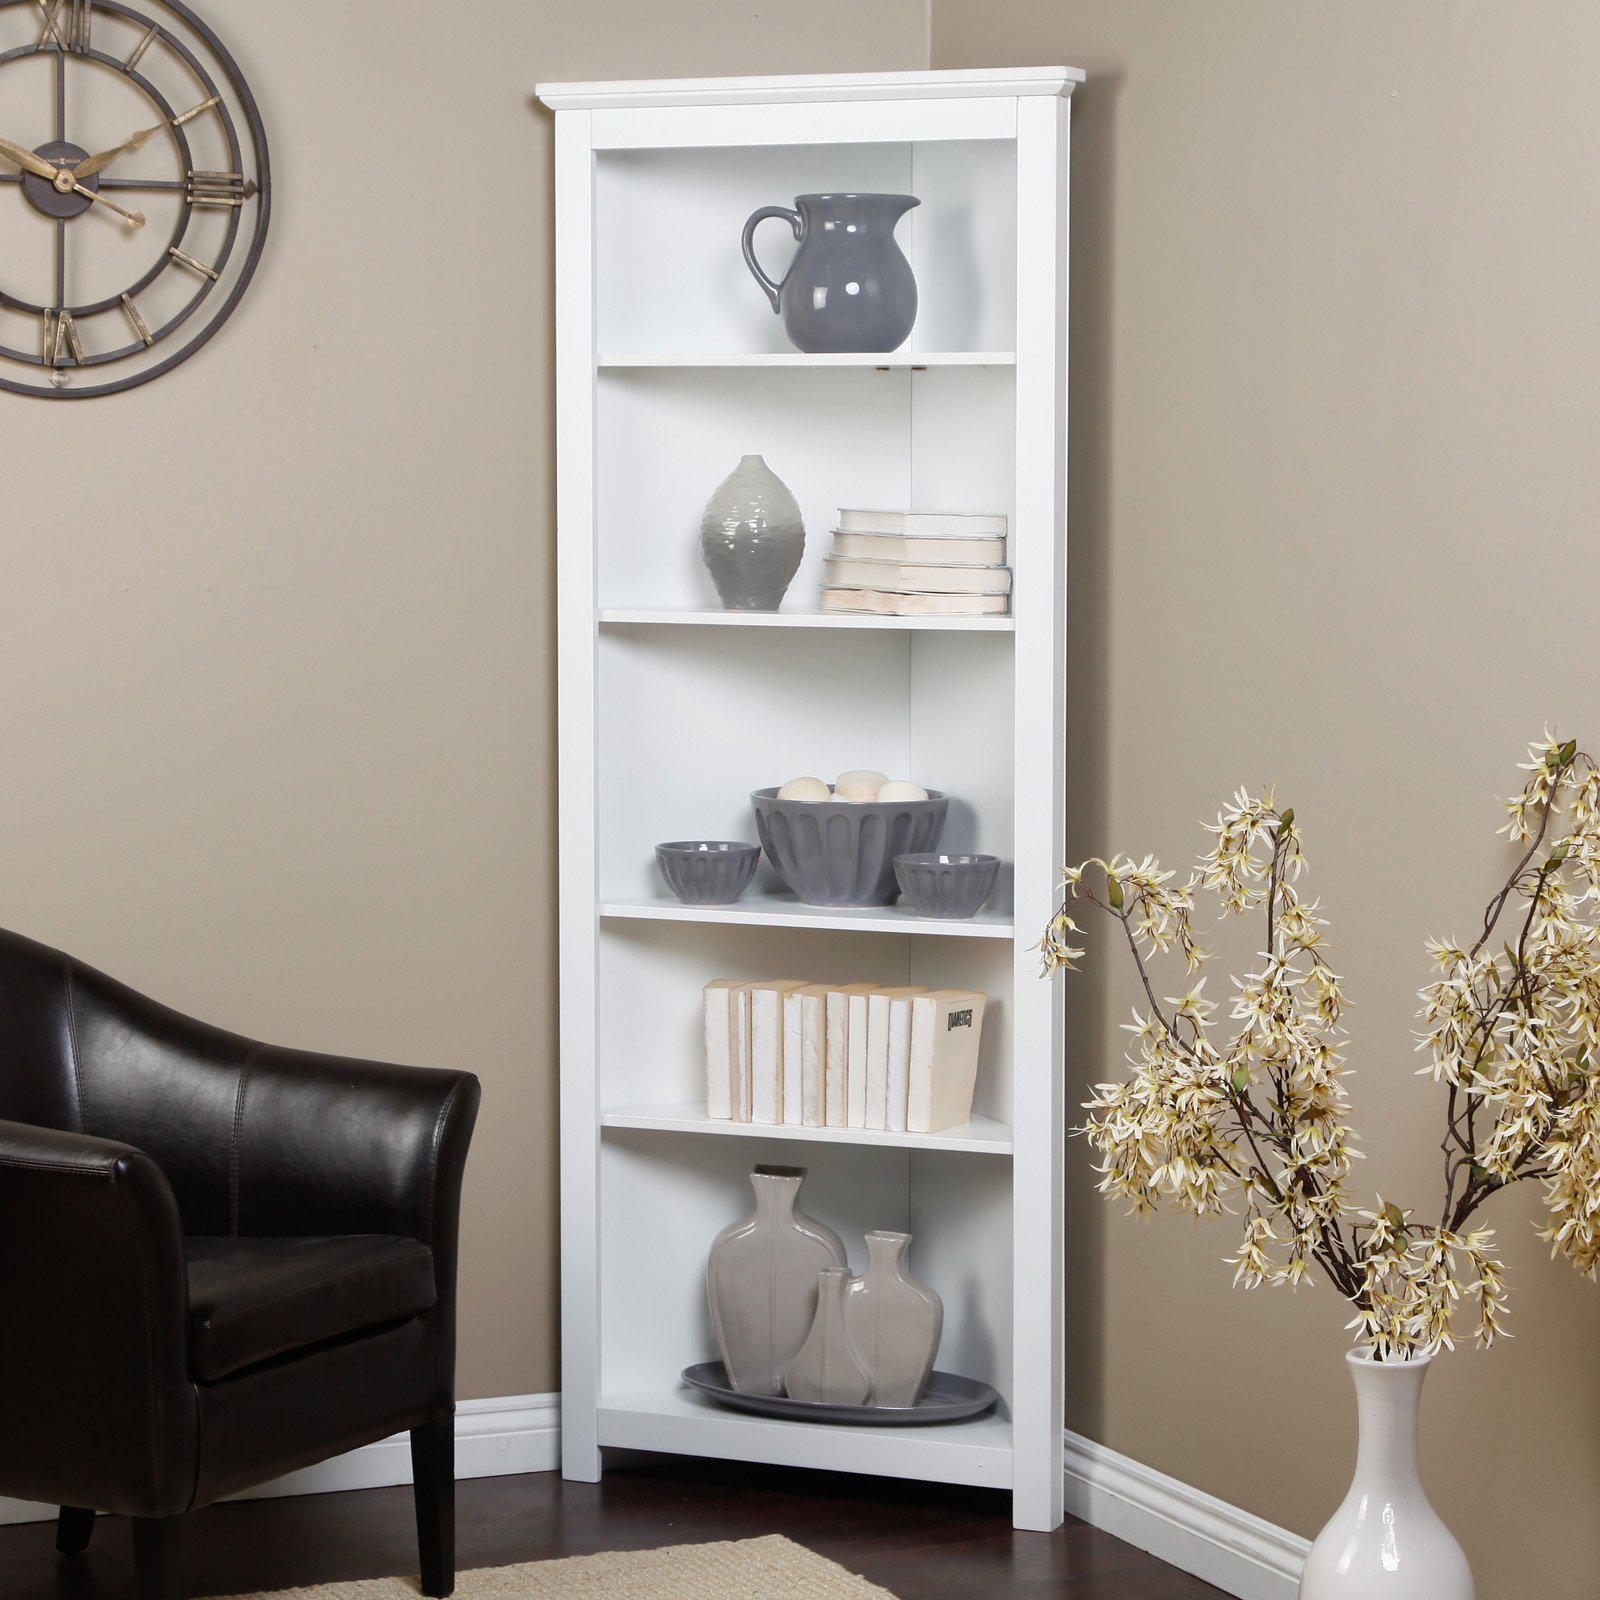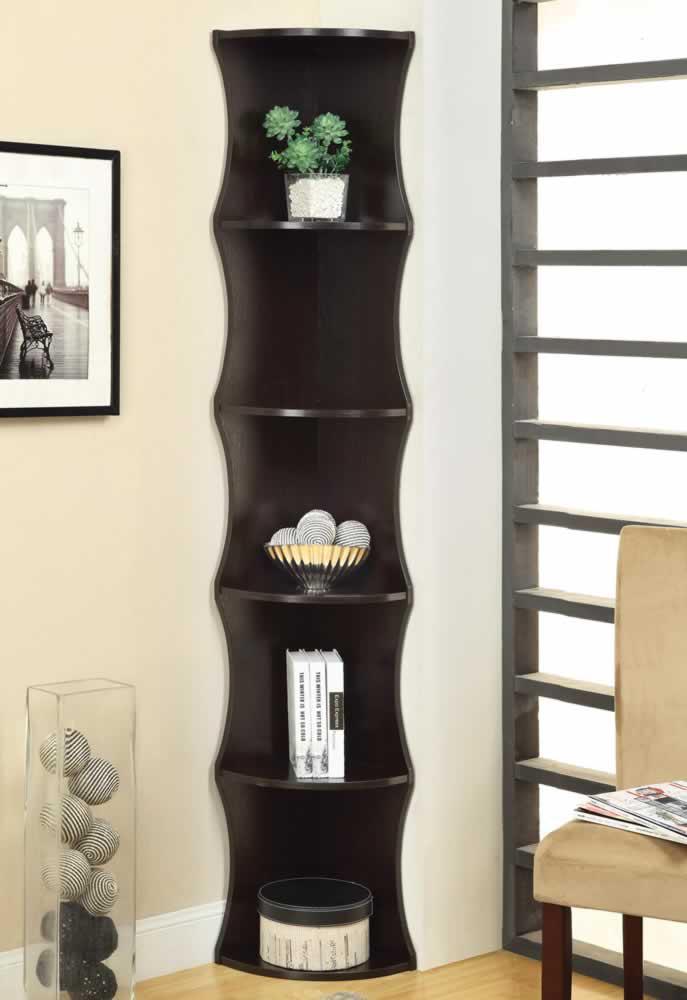The first image is the image on the left, the second image is the image on the right. Evaluate the accuracy of this statement regarding the images: "An image shows a right-angle white corner cabinet, with a solid back and five shelves.". Is it true? Answer yes or no. Yes. The first image is the image on the left, the second image is the image on the right. For the images shown, is this caption "A corner shelf unit is next to a window with long white drapes" true? Answer yes or no. No. 